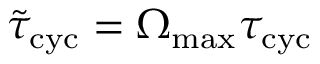<formula> <loc_0><loc_0><loc_500><loc_500>\tilde { \tau } _ { c y c } = \Omega _ { \max } \tau _ { c y c }</formula> 